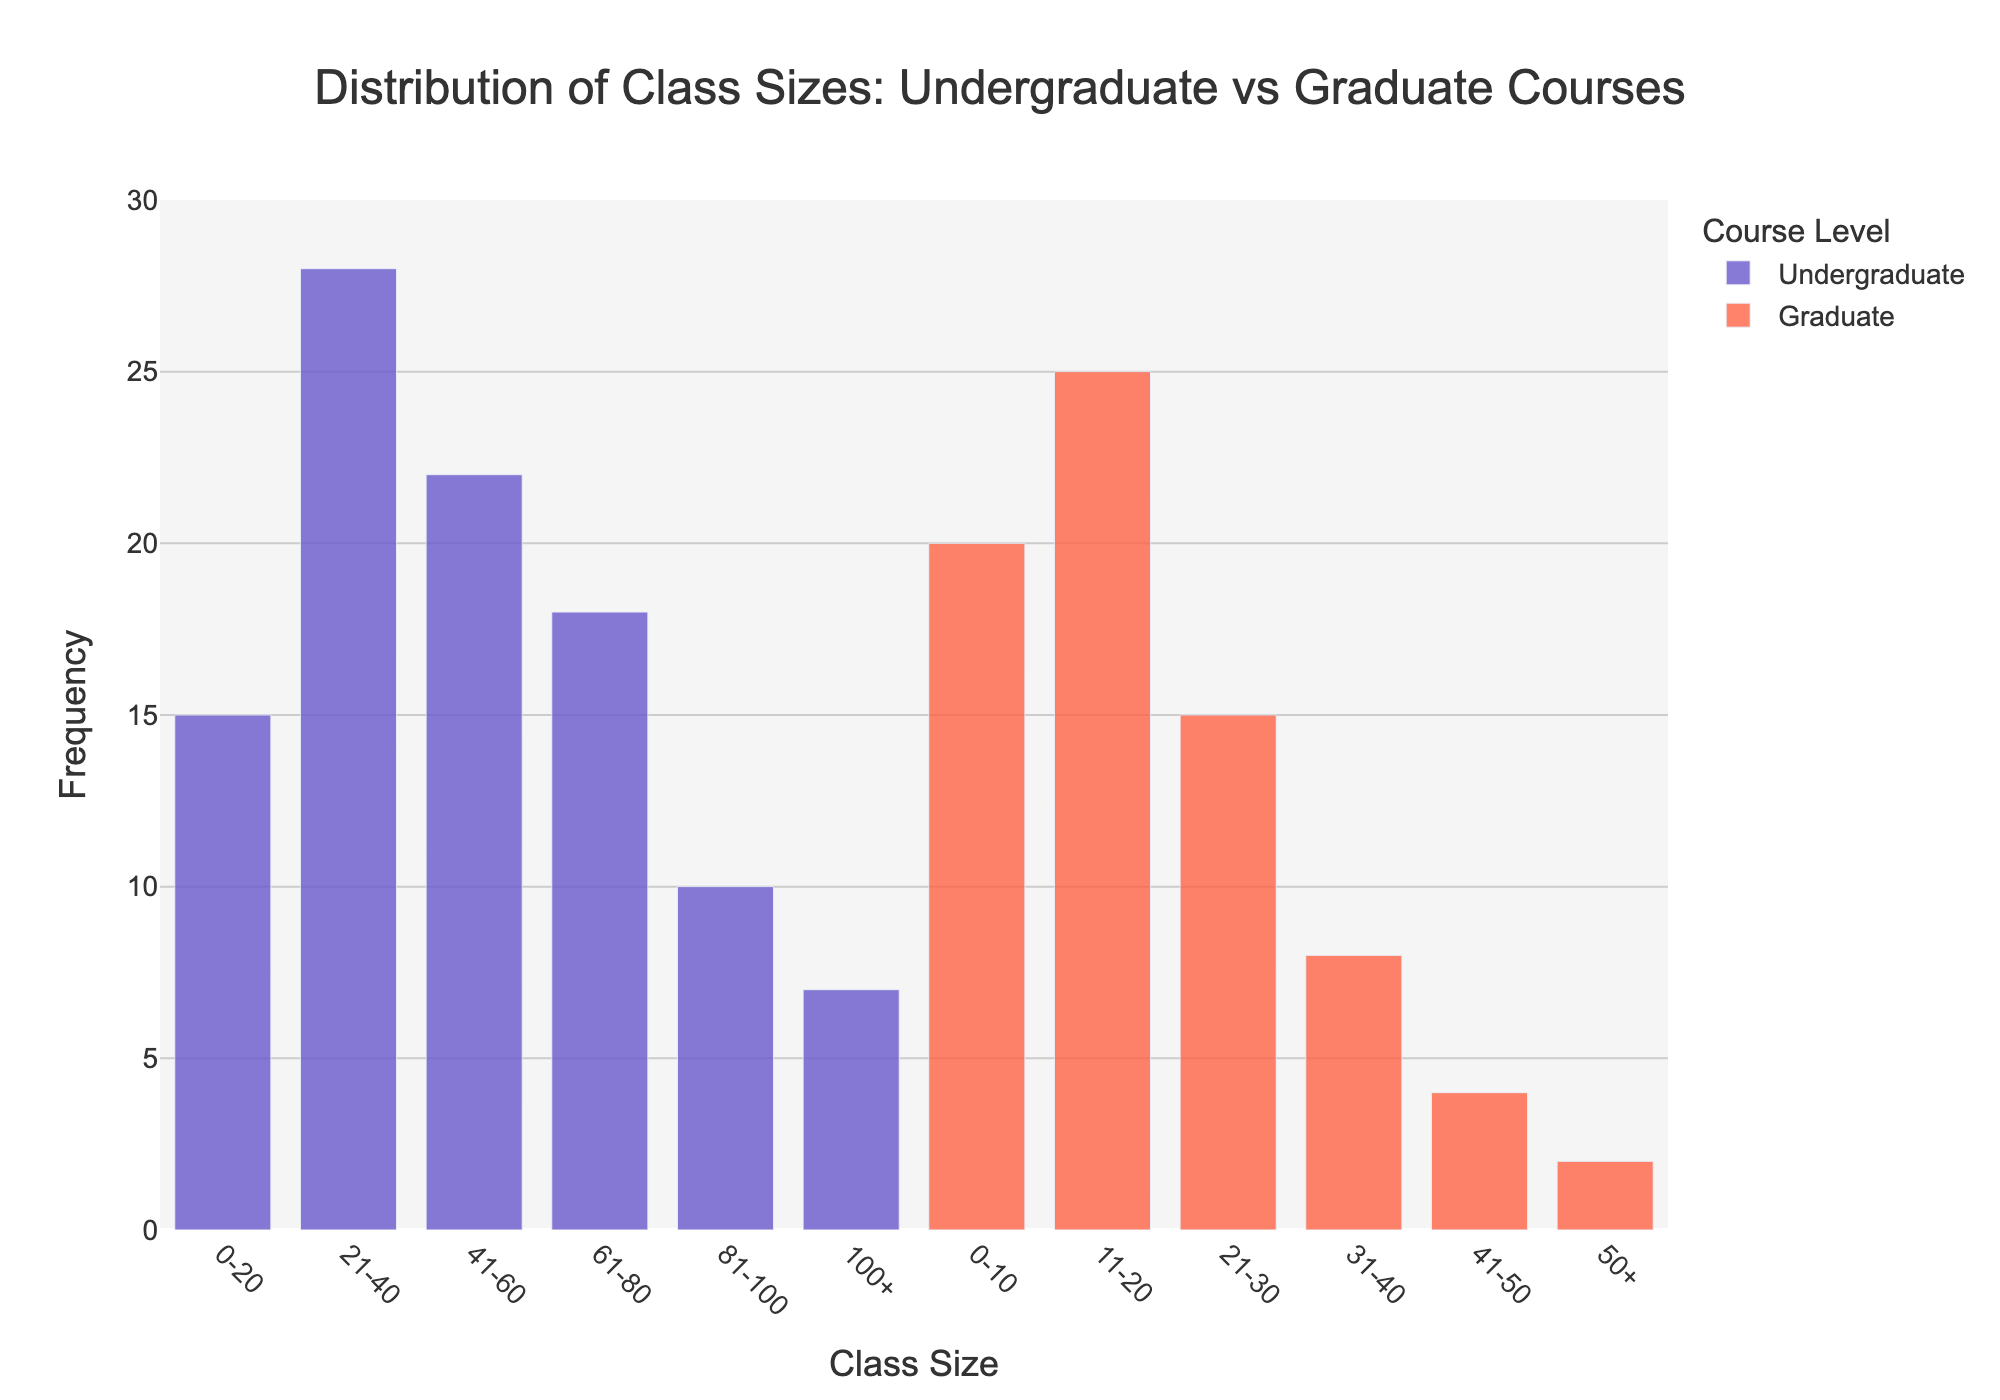what is the title of the figure? The title of the figure is usually placed at the top for easy identification. It reads, "Distribution of Class Sizes: Undergraduate vs Graduate Courses".
Answer: Distribution of Class Sizes: Undergraduate vs Graduate Courses What are the colors used for undergraduate and graduate courses in this figure? The colors used can be identified by looking at the legend. Undergraduate courses are represented by a shade of blue, and graduate courses are shown in a shade of red.
Answer: Blue for Undergraduate, Red for Graduate How many class size categories are there for undergraduate courses? By counting the distinct class size categories on the x-axis for undergraduate courses, we can see there are six categories: 0-20, 21-40, 41-60, 61-80, 81-100, and 100+.
Answer: Six categories Which class size category has the highest frequency for undergraduate courses? By observing the height of the bars for undergraduate courses, the tallest bar corresponds to the 21-40 class size category.
Answer: 21-40 What is the total frequency of graduate classes in the 0-20 class size range? We need to sum the frequencies for the 0-10 and 11-20 class size categories for graduate courses. These two frequencies are 20 and 25. Adding them gives us a total of 45.
Answer: 45 How does the frequency of graduate classes in the 21-30 range compare to undergraduate classes in the 41-60 range? Comparing the bar heights, we find that the frequency for graduate classes in the 21-30 range is 15, whereas the frequency for undergraduate classes in the 41-60 range is 22. Therefore, the undergraduate class frequency is higher.
Answer: Undergraduate is higher Which class size category has the lowest frequency for graduate courses? By identifying the shortest bar for graduate courses, we can see that the 50+ class size category has the lowest frequency, with a value of 2.
Answer: 50+ What is the combined frequency of undergraduate classes for the 61-100+ class size categories? The combined frequency is the sum of frequencies for the 61-80, 81-100, and 100+ categories. These are 18, 10, and 7 respectively. Summing these values gives us 35.
Answer: 35 What is the range of the y-axis, and what is the interval for the tick marks? The y-axis ranges from 0 to 30, and the tick marks have an interval of 5, as observed from the tick labels on the y-axis.
Answer: 0 to 30 with an interval of 5 